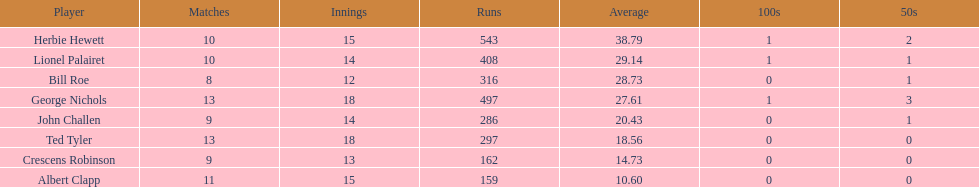Identify a player with an average exceeding 2 Herbie Hewett. 